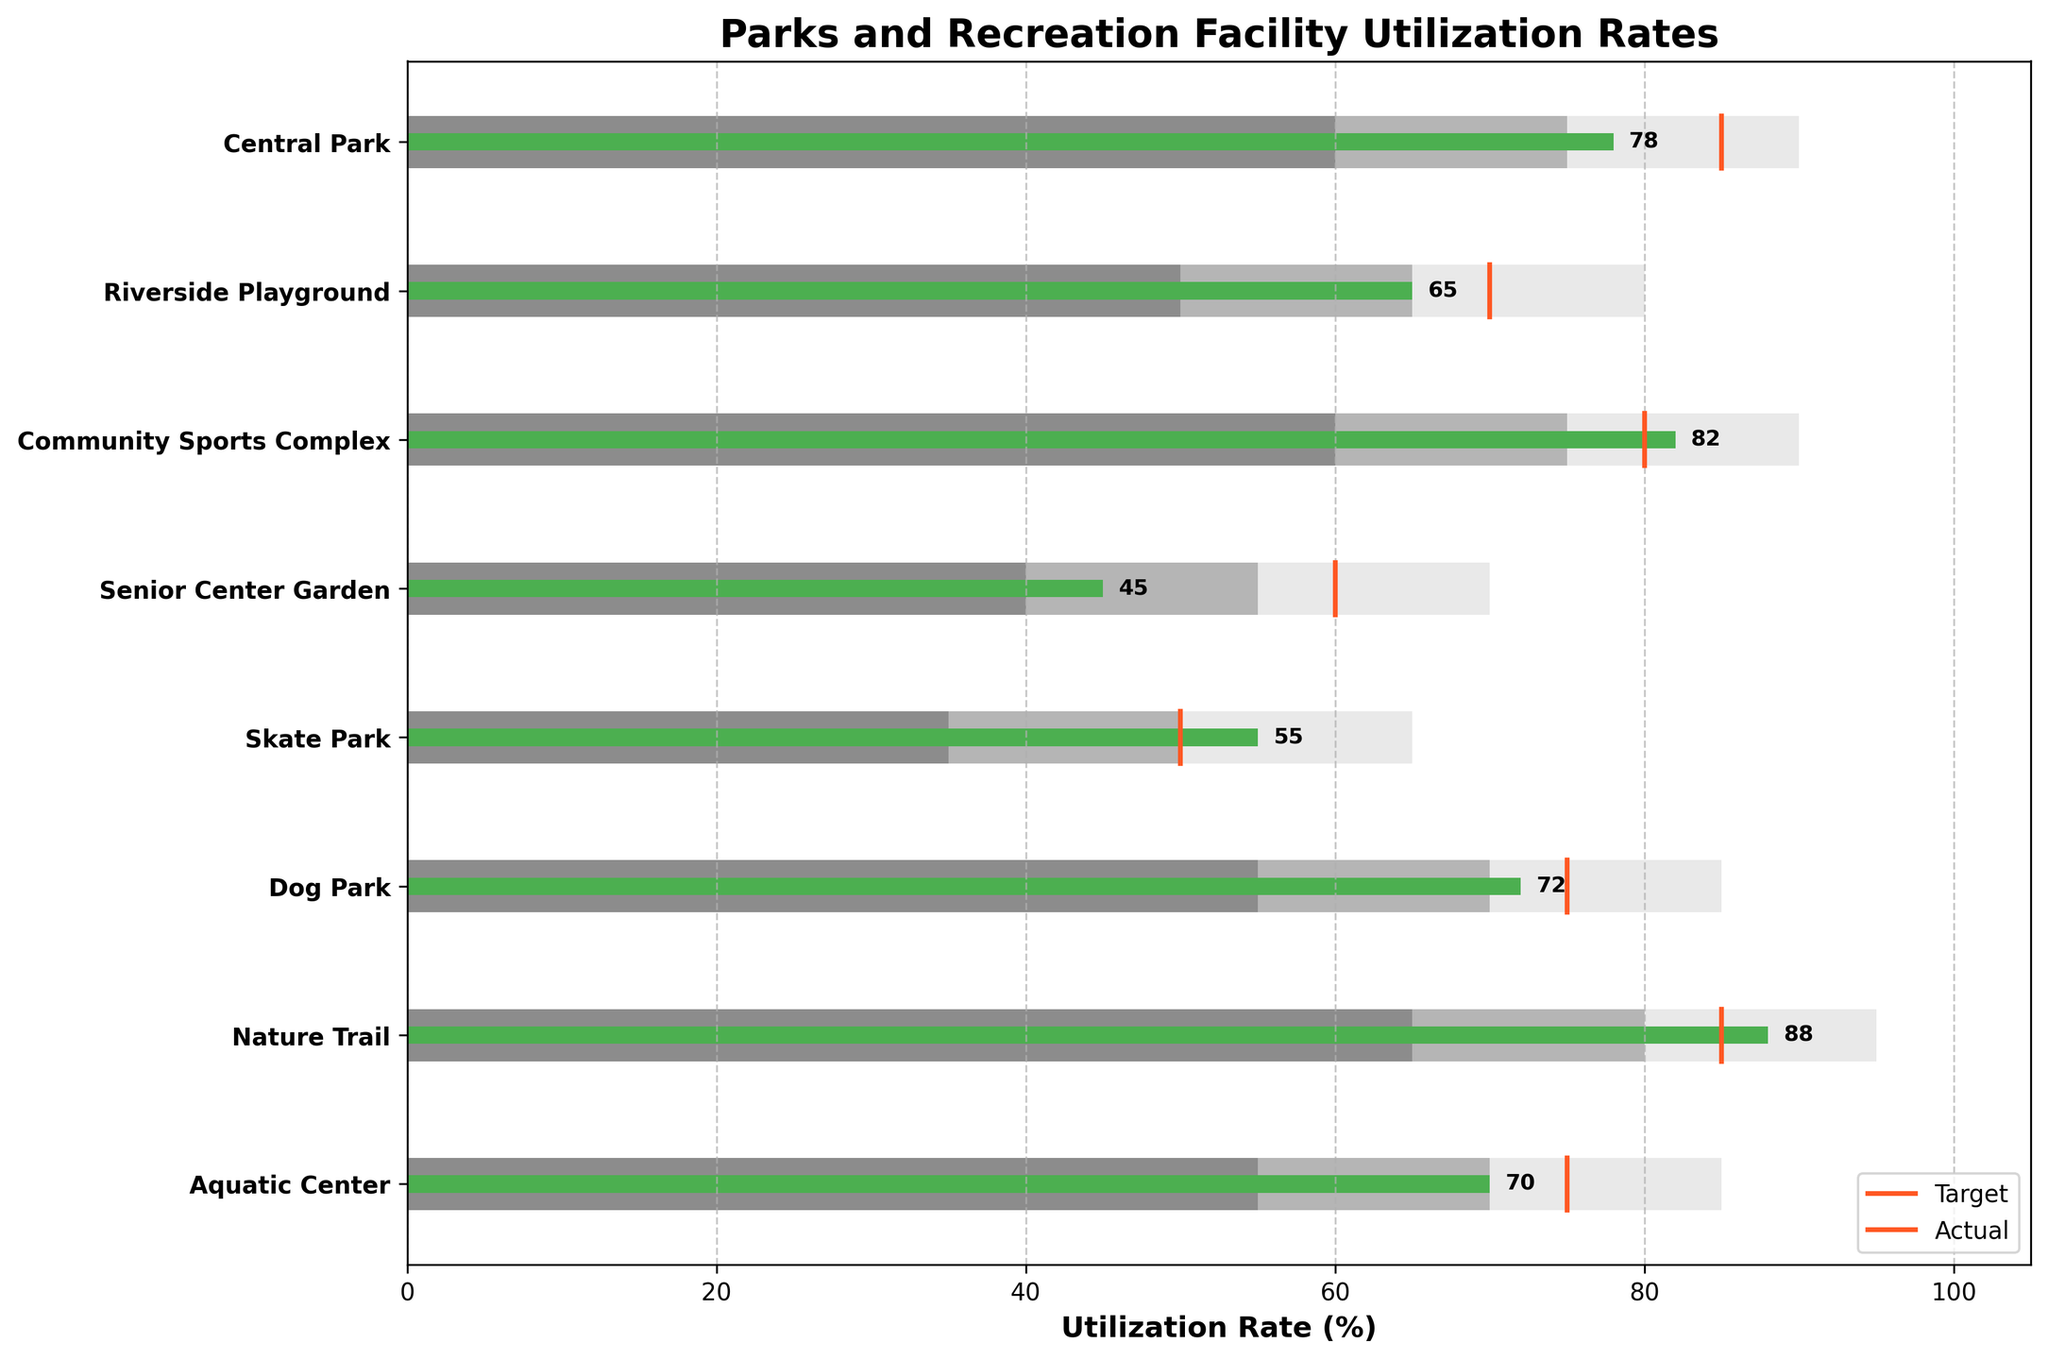What is the title of the figure? The title of the figure is usually displayed prominently at the top of the plot. In this case, it's labeled, so refer to the plot to read the title.
Answer: Parks and Recreation Facility Utilization Rates Which facility has the highest utilization rate? Examine the green bars representing actual utilization rates. The longest green bar signifies the highest utilization rate.
Answer: Nature Trail How does the Central Park utilization rate compare to its target? Look at the green bar for Central Park for actual usage, then compare it to the orange line indicating the target.
Answer: 78% compared to 85% What is the range for the low utilization category for Riverside Playground? The low utilization range is depicted by the darkest grey bar. Refer to this bar's starting and ending points for Riverside Playground.
Answer: 50 to 65% Which facilities have met or exceeded their target utilization rates? Identify the facilities where the green bar (actual utilization) meets or surpasses the orange target line.
Answer: Community Sports Complex, Skate Park What is the difference between the actual and target utilization rates for the Aquatic Center? Subtract the actual utilization rate (green bar) from the target rate (orange line) for the Aquatic Center.
Answer: 70 - 75 = -5% How many facilities have an actual utilization rate above 70%? Count the number of green bars that exceed the 70% mark along the x-axis.
Answer: 5 Which facility has the smallest gap between its actual and target utilization rates? Calculate the differences between actual and target rates for all facilities and find the smallest value.
Answer: Skate Park What are the utilization rates required to be in the high range for Senior Center Garden? Look at the highest grey bar segment for Senior Center Garden and note its starting and ending points.
Answer: 55 to 70% Which facility falls into the low utilization category but has the closest actual rate to the high range? Check for facilities with actual usage rates within the low range segment and identify the one closest to the high range threshold.
Answer: Senior Center Garden 